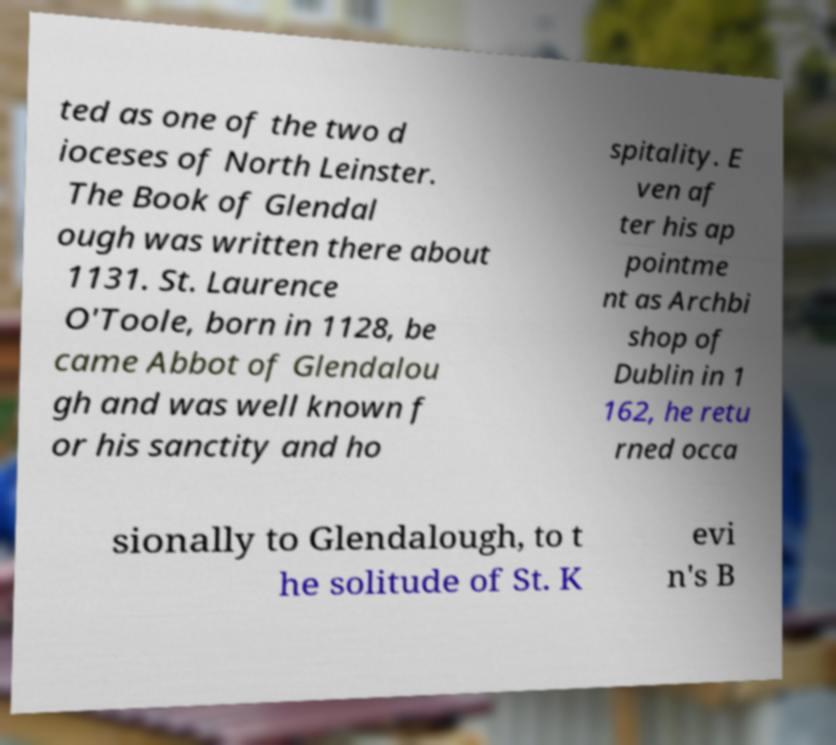There's text embedded in this image that I need extracted. Can you transcribe it verbatim? ted as one of the two d ioceses of North Leinster. The Book of Glendal ough was written there about 1131. St. Laurence O'Toole, born in 1128, be came Abbot of Glendalou gh and was well known f or his sanctity and ho spitality. E ven af ter his ap pointme nt as Archbi shop of Dublin in 1 162, he retu rned occa sionally to Glendalough, to t he solitude of St. K evi n's B 